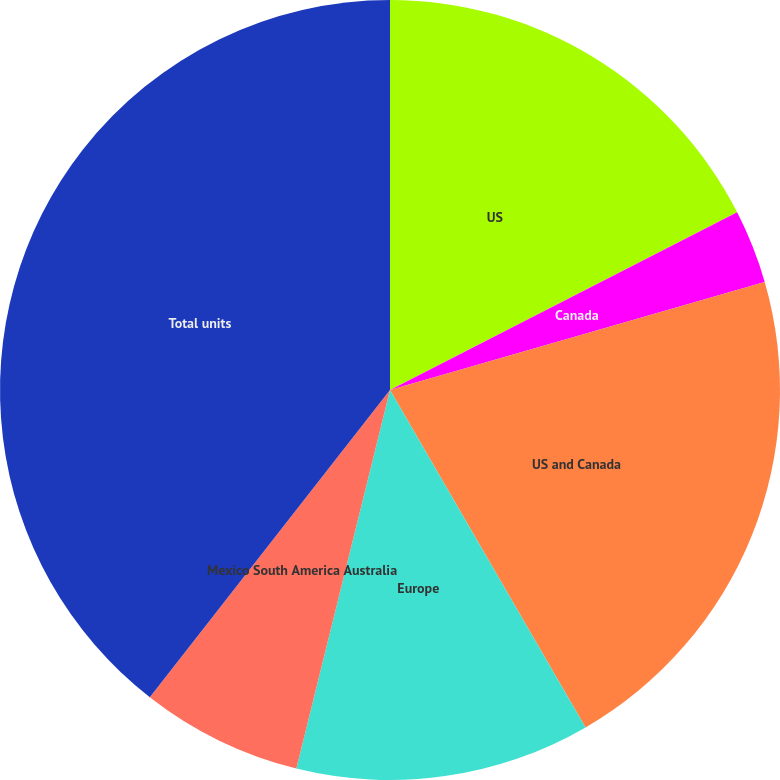Convert chart to OTSL. <chart><loc_0><loc_0><loc_500><loc_500><pie_chart><fcel>US<fcel>Canada<fcel>US and Canada<fcel>Europe<fcel>Mexico South America Australia<fcel>Total units<nl><fcel>17.47%<fcel>3.06%<fcel>21.11%<fcel>12.22%<fcel>6.7%<fcel>39.44%<nl></chart> 